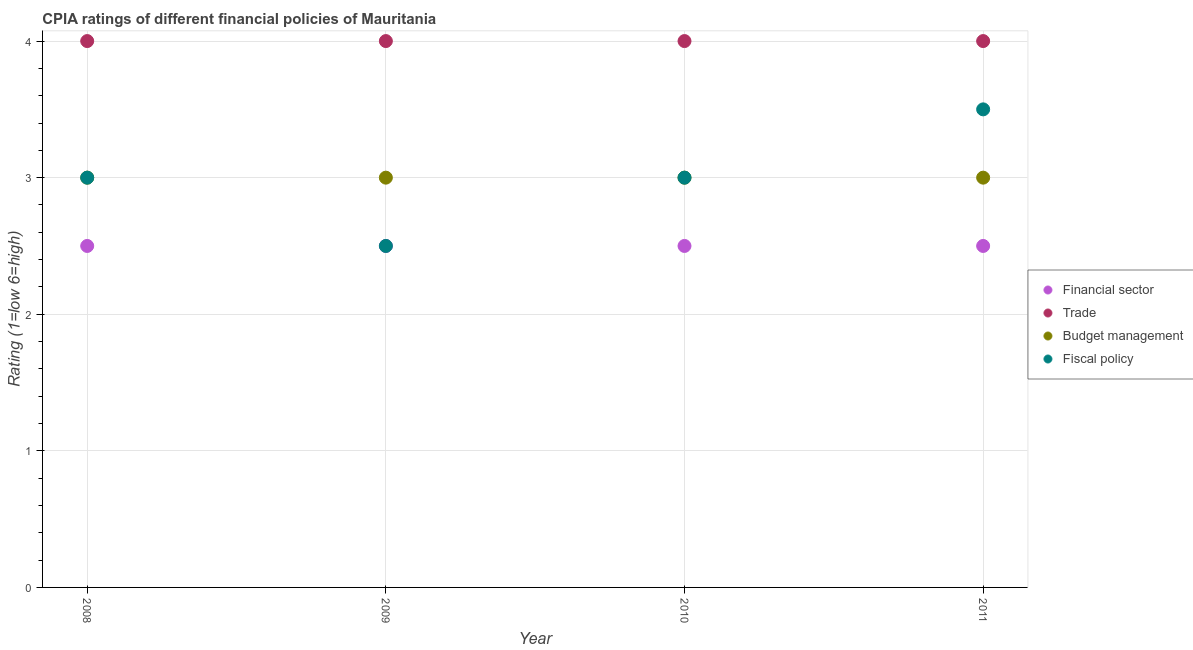How many different coloured dotlines are there?
Ensure brevity in your answer.  4. Is the number of dotlines equal to the number of legend labels?
Keep it short and to the point. Yes. Across all years, what is the minimum cpia rating of financial sector?
Give a very brief answer. 2.5. What is the total cpia rating of trade in the graph?
Your answer should be compact. 16. What is the difference between the cpia rating of trade in 2008 and that in 2010?
Give a very brief answer. 0. What is the difference between the cpia rating of budget management in 2011 and the cpia rating of fiscal policy in 2008?
Provide a short and direct response. 0. Is the cpia rating of budget management in 2010 less than that in 2011?
Ensure brevity in your answer.  No. What is the difference between the highest and the second highest cpia rating of trade?
Provide a succinct answer. 0. What is the difference between the highest and the lowest cpia rating of trade?
Your answer should be compact. 0. In how many years, is the cpia rating of trade greater than the average cpia rating of trade taken over all years?
Your response must be concise. 0. Is it the case that in every year, the sum of the cpia rating of trade and cpia rating of budget management is greater than the sum of cpia rating of financial sector and cpia rating of fiscal policy?
Your response must be concise. Yes. Does the cpia rating of trade monotonically increase over the years?
Your answer should be compact. No. Is the cpia rating of budget management strictly greater than the cpia rating of financial sector over the years?
Your answer should be compact. Yes. Is the cpia rating of financial sector strictly less than the cpia rating of budget management over the years?
Give a very brief answer. Yes. How many years are there in the graph?
Your response must be concise. 4. What is the difference between two consecutive major ticks on the Y-axis?
Make the answer very short. 1. Are the values on the major ticks of Y-axis written in scientific E-notation?
Offer a terse response. No. Does the graph contain any zero values?
Your answer should be very brief. No. Does the graph contain grids?
Your answer should be compact. Yes. Where does the legend appear in the graph?
Ensure brevity in your answer.  Center right. How many legend labels are there?
Keep it short and to the point. 4. What is the title of the graph?
Your response must be concise. CPIA ratings of different financial policies of Mauritania. Does "Tracking ability" appear as one of the legend labels in the graph?
Give a very brief answer. No. What is the label or title of the X-axis?
Offer a very short reply. Year. What is the Rating (1=low 6=high) of Financial sector in 2008?
Your answer should be very brief. 2.5. What is the Rating (1=low 6=high) in Trade in 2008?
Offer a very short reply. 4. What is the Rating (1=low 6=high) of Budget management in 2008?
Your answer should be very brief. 3. What is the Rating (1=low 6=high) of Fiscal policy in 2008?
Your answer should be compact. 3. What is the Rating (1=low 6=high) in Financial sector in 2009?
Make the answer very short. 2.5. What is the Rating (1=low 6=high) in Budget management in 2009?
Keep it short and to the point. 3. What is the Rating (1=low 6=high) in Trade in 2010?
Keep it short and to the point. 4. What is the Rating (1=low 6=high) in Budget management in 2011?
Your answer should be compact. 3. What is the Rating (1=low 6=high) in Fiscal policy in 2011?
Make the answer very short. 3.5. Across all years, what is the maximum Rating (1=low 6=high) in Financial sector?
Offer a very short reply. 2.5. Across all years, what is the maximum Rating (1=low 6=high) in Budget management?
Ensure brevity in your answer.  3. Across all years, what is the maximum Rating (1=low 6=high) in Fiscal policy?
Provide a succinct answer. 3.5. Across all years, what is the minimum Rating (1=low 6=high) of Fiscal policy?
Your answer should be very brief. 2.5. What is the total Rating (1=low 6=high) in Financial sector in the graph?
Provide a succinct answer. 10. What is the total Rating (1=low 6=high) in Fiscal policy in the graph?
Make the answer very short. 12. What is the difference between the Rating (1=low 6=high) in Trade in 2008 and that in 2009?
Keep it short and to the point. 0. What is the difference between the Rating (1=low 6=high) of Fiscal policy in 2008 and that in 2009?
Offer a very short reply. 0.5. What is the difference between the Rating (1=low 6=high) of Trade in 2008 and that in 2010?
Provide a short and direct response. 0. What is the difference between the Rating (1=low 6=high) of Budget management in 2008 and that in 2010?
Make the answer very short. 0. What is the difference between the Rating (1=low 6=high) of Fiscal policy in 2008 and that in 2010?
Offer a terse response. 0. What is the difference between the Rating (1=low 6=high) in Trade in 2008 and that in 2011?
Your response must be concise. 0. What is the difference between the Rating (1=low 6=high) in Financial sector in 2009 and that in 2010?
Provide a short and direct response. 0. What is the difference between the Rating (1=low 6=high) in Fiscal policy in 2009 and that in 2010?
Your answer should be very brief. -0.5. What is the difference between the Rating (1=low 6=high) in Financial sector in 2009 and that in 2011?
Your response must be concise. 0. What is the difference between the Rating (1=low 6=high) of Budget management in 2009 and that in 2011?
Offer a very short reply. 0. What is the difference between the Rating (1=low 6=high) in Fiscal policy in 2009 and that in 2011?
Ensure brevity in your answer.  -1. What is the difference between the Rating (1=low 6=high) of Financial sector in 2010 and that in 2011?
Your response must be concise. 0. What is the difference between the Rating (1=low 6=high) in Trade in 2010 and that in 2011?
Give a very brief answer. 0. What is the difference between the Rating (1=low 6=high) in Budget management in 2010 and that in 2011?
Make the answer very short. 0. What is the difference between the Rating (1=low 6=high) in Trade in 2008 and the Rating (1=low 6=high) in Fiscal policy in 2009?
Your response must be concise. 1.5. What is the difference between the Rating (1=low 6=high) in Budget management in 2008 and the Rating (1=low 6=high) in Fiscal policy in 2009?
Ensure brevity in your answer.  0.5. What is the difference between the Rating (1=low 6=high) in Financial sector in 2008 and the Rating (1=low 6=high) in Trade in 2010?
Your answer should be compact. -1.5. What is the difference between the Rating (1=low 6=high) of Financial sector in 2008 and the Rating (1=low 6=high) of Fiscal policy in 2010?
Your response must be concise. -0.5. What is the difference between the Rating (1=low 6=high) in Trade in 2008 and the Rating (1=low 6=high) in Fiscal policy in 2010?
Ensure brevity in your answer.  1. What is the difference between the Rating (1=low 6=high) in Financial sector in 2008 and the Rating (1=low 6=high) in Trade in 2011?
Your answer should be compact. -1.5. What is the difference between the Rating (1=low 6=high) in Trade in 2008 and the Rating (1=low 6=high) in Fiscal policy in 2011?
Ensure brevity in your answer.  0.5. What is the difference between the Rating (1=low 6=high) in Budget management in 2008 and the Rating (1=low 6=high) in Fiscal policy in 2011?
Give a very brief answer. -0.5. What is the difference between the Rating (1=low 6=high) in Financial sector in 2009 and the Rating (1=low 6=high) in Trade in 2010?
Your response must be concise. -1.5. What is the difference between the Rating (1=low 6=high) in Financial sector in 2009 and the Rating (1=low 6=high) in Budget management in 2010?
Keep it short and to the point. -0.5. What is the difference between the Rating (1=low 6=high) in Financial sector in 2009 and the Rating (1=low 6=high) in Fiscal policy in 2010?
Make the answer very short. -0.5. What is the difference between the Rating (1=low 6=high) of Budget management in 2009 and the Rating (1=low 6=high) of Fiscal policy in 2010?
Make the answer very short. 0. What is the difference between the Rating (1=low 6=high) of Financial sector in 2009 and the Rating (1=low 6=high) of Budget management in 2011?
Offer a terse response. -0.5. What is the difference between the Rating (1=low 6=high) in Financial sector in 2009 and the Rating (1=low 6=high) in Fiscal policy in 2011?
Provide a succinct answer. -1. What is the difference between the Rating (1=low 6=high) in Financial sector in 2010 and the Rating (1=low 6=high) in Trade in 2011?
Provide a short and direct response. -1.5. What is the difference between the Rating (1=low 6=high) of Financial sector in 2010 and the Rating (1=low 6=high) of Budget management in 2011?
Your answer should be compact. -0.5. What is the difference between the Rating (1=low 6=high) of Trade in 2010 and the Rating (1=low 6=high) of Fiscal policy in 2011?
Provide a short and direct response. 0.5. What is the difference between the Rating (1=low 6=high) of Budget management in 2010 and the Rating (1=low 6=high) of Fiscal policy in 2011?
Make the answer very short. -0.5. What is the average Rating (1=low 6=high) of Budget management per year?
Offer a very short reply. 3. In the year 2008, what is the difference between the Rating (1=low 6=high) in Financial sector and Rating (1=low 6=high) in Trade?
Offer a terse response. -1.5. In the year 2009, what is the difference between the Rating (1=low 6=high) in Financial sector and Rating (1=low 6=high) in Budget management?
Offer a terse response. -0.5. In the year 2009, what is the difference between the Rating (1=low 6=high) of Financial sector and Rating (1=low 6=high) of Fiscal policy?
Your answer should be compact. 0. In the year 2009, what is the difference between the Rating (1=low 6=high) of Trade and Rating (1=low 6=high) of Budget management?
Provide a succinct answer. 1. In the year 2009, what is the difference between the Rating (1=low 6=high) of Budget management and Rating (1=low 6=high) of Fiscal policy?
Offer a very short reply. 0.5. In the year 2010, what is the difference between the Rating (1=low 6=high) of Financial sector and Rating (1=low 6=high) of Trade?
Make the answer very short. -1.5. In the year 2010, what is the difference between the Rating (1=low 6=high) of Financial sector and Rating (1=low 6=high) of Budget management?
Offer a very short reply. -0.5. In the year 2010, what is the difference between the Rating (1=low 6=high) of Financial sector and Rating (1=low 6=high) of Fiscal policy?
Provide a succinct answer. -0.5. In the year 2010, what is the difference between the Rating (1=low 6=high) in Trade and Rating (1=low 6=high) in Budget management?
Provide a short and direct response. 1. In the year 2011, what is the difference between the Rating (1=low 6=high) of Financial sector and Rating (1=low 6=high) of Budget management?
Your response must be concise. -0.5. In the year 2011, what is the difference between the Rating (1=low 6=high) in Financial sector and Rating (1=low 6=high) in Fiscal policy?
Provide a succinct answer. -1. In the year 2011, what is the difference between the Rating (1=low 6=high) of Trade and Rating (1=low 6=high) of Budget management?
Keep it short and to the point. 1. In the year 2011, what is the difference between the Rating (1=low 6=high) in Trade and Rating (1=low 6=high) in Fiscal policy?
Provide a succinct answer. 0.5. What is the ratio of the Rating (1=low 6=high) in Fiscal policy in 2008 to that in 2009?
Give a very brief answer. 1.2. What is the ratio of the Rating (1=low 6=high) in Trade in 2008 to that in 2010?
Give a very brief answer. 1. What is the ratio of the Rating (1=low 6=high) of Budget management in 2008 to that in 2010?
Provide a succinct answer. 1. What is the ratio of the Rating (1=low 6=high) of Fiscal policy in 2008 to that in 2010?
Ensure brevity in your answer.  1. What is the ratio of the Rating (1=low 6=high) in Financial sector in 2008 to that in 2011?
Make the answer very short. 1. What is the ratio of the Rating (1=low 6=high) in Trade in 2008 to that in 2011?
Your answer should be very brief. 1. What is the ratio of the Rating (1=low 6=high) of Budget management in 2008 to that in 2011?
Ensure brevity in your answer.  1. What is the ratio of the Rating (1=low 6=high) in Fiscal policy in 2008 to that in 2011?
Ensure brevity in your answer.  0.86. What is the ratio of the Rating (1=low 6=high) in Budget management in 2009 to that in 2010?
Your answer should be very brief. 1. What is the ratio of the Rating (1=low 6=high) in Trade in 2009 to that in 2011?
Your answer should be very brief. 1. What is the ratio of the Rating (1=low 6=high) of Fiscal policy in 2009 to that in 2011?
Make the answer very short. 0.71. What is the ratio of the Rating (1=low 6=high) of Trade in 2010 to that in 2011?
Give a very brief answer. 1. What is the ratio of the Rating (1=low 6=high) in Fiscal policy in 2010 to that in 2011?
Your response must be concise. 0.86. What is the difference between the highest and the second highest Rating (1=low 6=high) of Budget management?
Provide a succinct answer. 0. What is the difference between the highest and the second highest Rating (1=low 6=high) in Fiscal policy?
Offer a terse response. 0.5. What is the difference between the highest and the lowest Rating (1=low 6=high) of Financial sector?
Offer a terse response. 0. What is the difference between the highest and the lowest Rating (1=low 6=high) in Trade?
Offer a terse response. 0. What is the difference between the highest and the lowest Rating (1=low 6=high) in Budget management?
Offer a terse response. 0. 